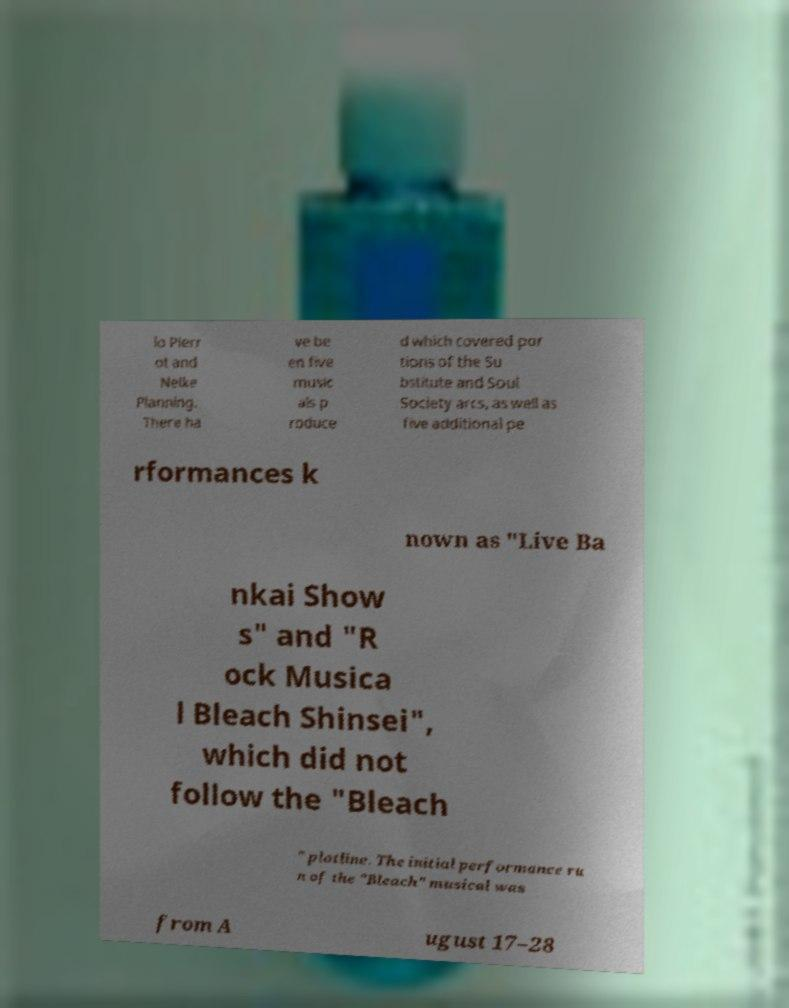Please read and relay the text visible in this image. What does it say? io Pierr ot and Nelke Planning. There ha ve be en five music als p roduce d which covered por tions of the Su bstitute and Soul Society arcs, as well as five additional pe rformances k nown as "Live Ba nkai Show s" and "R ock Musica l Bleach Shinsei", which did not follow the "Bleach " plotline. The initial performance ru n of the "Bleach" musical was from A ugust 17–28 